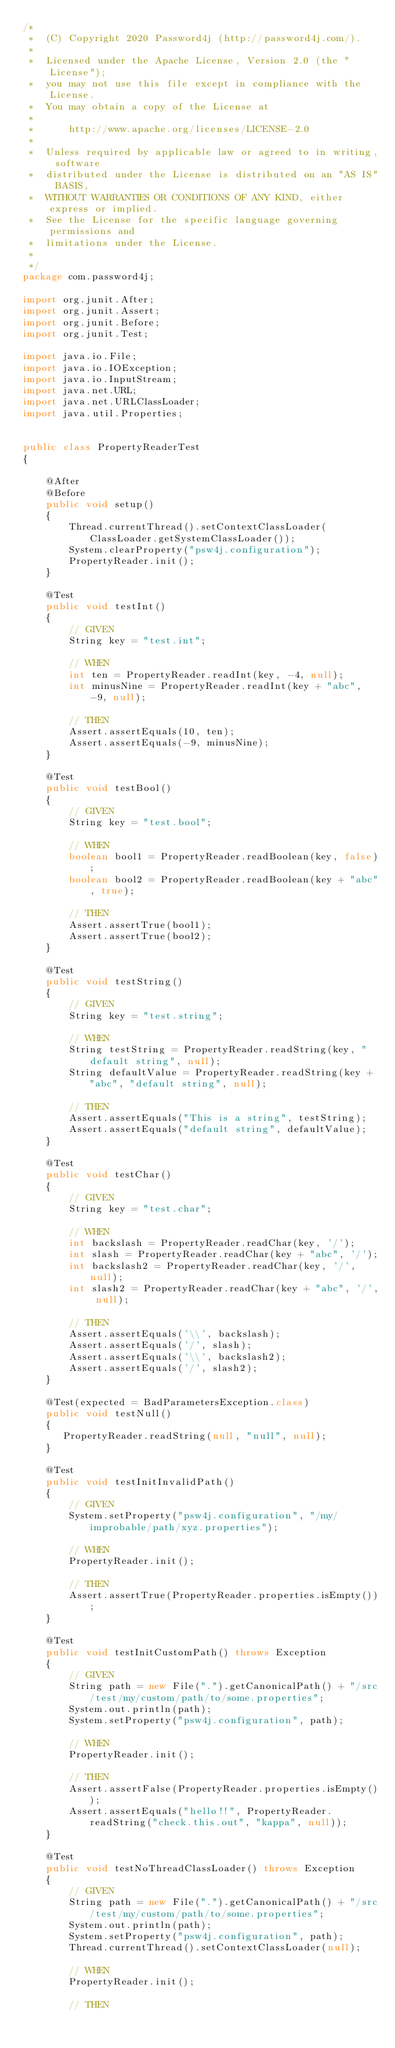Convert code to text. <code><loc_0><loc_0><loc_500><loc_500><_Java_>/*
 *  (C) Copyright 2020 Password4j (http://password4j.com/).
 *
 *  Licensed under the Apache License, Version 2.0 (the "License");
 *  you may not use this file except in compliance with the License.
 *  You may obtain a copy of the License at
 *
 *      http://www.apache.org/licenses/LICENSE-2.0
 *
 *  Unless required by applicable law or agreed to in writing, software
 *  distributed under the License is distributed on an "AS IS" BASIS,
 *  WITHOUT WARRANTIES OR CONDITIONS OF ANY KIND, either express or implied.
 *  See the License for the specific language governing permissions and
 *  limitations under the License.
 *
 */
package com.password4j;

import org.junit.After;
import org.junit.Assert;
import org.junit.Before;
import org.junit.Test;

import java.io.File;
import java.io.IOException;
import java.io.InputStream;
import java.net.URL;
import java.net.URLClassLoader;
import java.util.Properties;


public class PropertyReaderTest
{

    @After
    @Before
    public void setup()
    {
        Thread.currentThread().setContextClassLoader(ClassLoader.getSystemClassLoader());
        System.clearProperty("psw4j.configuration");
        PropertyReader.init();
    }

    @Test
    public void testInt()
    {
        // GIVEN
        String key = "test.int";

        // WHEN
        int ten = PropertyReader.readInt(key, -4, null);
        int minusNine = PropertyReader.readInt(key + "abc", -9, null);

        // THEN
        Assert.assertEquals(10, ten);
        Assert.assertEquals(-9, minusNine);
    }

    @Test
    public void testBool()
    {
        // GIVEN
        String key = "test.bool";

        // WHEN
        boolean bool1 = PropertyReader.readBoolean(key, false);
        boolean bool2 = PropertyReader.readBoolean(key + "abc", true);

        // THEN
        Assert.assertTrue(bool1);
        Assert.assertTrue(bool2);
    }

    @Test
    public void testString()
    {
        // GIVEN
        String key = "test.string";

        // WHEN
        String testString = PropertyReader.readString(key, "default string", null);
        String defaultValue = PropertyReader.readString(key + "abc", "default string", null);

        // THEN
        Assert.assertEquals("This is a string", testString);
        Assert.assertEquals("default string", defaultValue);
    }

    @Test
    public void testChar()
    {
        // GIVEN
        String key = "test.char";

        // WHEN
        int backslash = PropertyReader.readChar(key, '/');
        int slash = PropertyReader.readChar(key + "abc", '/');
        int backslash2 = PropertyReader.readChar(key, '/', null);
        int slash2 = PropertyReader.readChar(key + "abc", '/', null);

        // THEN
        Assert.assertEquals('\\', backslash);
        Assert.assertEquals('/', slash);
        Assert.assertEquals('\\', backslash2);
        Assert.assertEquals('/', slash2);
    }

    @Test(expected = BadParametersException.class)
    public void testNull()
    {
       PropertyReader.readString(null, "null", null);
    }

    @Test
    public void testInitInvalidPath()
    {
        // GIVEN
        System.setProperty("psw4j.configuration", "/my/improbable/path/xyz.properties");

        // WHEN
        PropertyReader.init();

        // THEN
        Assert.assertTrue(PropertyReader.properties.isEmpty());
    }

    @Test
    public void testInitCustomPath() throws Exception
    {
        // GIVEN
        String path = new File(".").getCanonicalPath() + "/src/test/my/custom/path/to/some.properties";
        System.out.println(path);
        System.setProperty("psw4j.configuration", path);

        // WHEN
        PropertyReader.init();

        // THEN
        Assert.assertFalse(PropertyReader.properties.isEmpty());
        Assert.assertEquals("hello!!", PropertyReader.readString("check.this.out", "kappa", null));
    }

    @Test
    public void testNoThreadClassLoader() throws Exception
    {
        // GIVEN
        String path = new File(".").getCanonicalPath() + "/src/test/my/custom/path/to/some.properties";
        System.out.println(path);
        System.setProperty("psw4j.configuration", path);
        Thread.currentThread().setContextClassLoader(null);

        // WHEN
        PropertyReader.init();

        // THEN</code> 